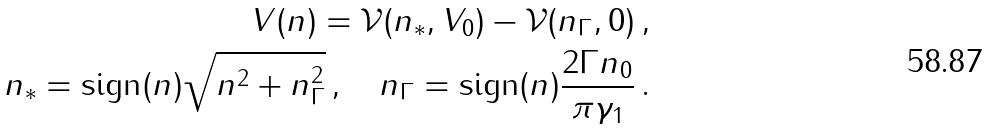Convert formula to latex. <formula><loc_0><loc_0><loc_500><loc_500>V ( n ) = \mathcal { V } ( n _ { * } , V _ { 0 } ) - \mathcal { V } ( n _ { \Gamma } , 0 ) \, , \\ n _ { * } = \text {sign} ( n ) \sqrt { n ^ { 2 } + n _ { \Gamma } ^ { 2 } } \, , \quad n _ { \Gamma } = \text {sign} ( n ) \frac { 2 \Gamma n _ { 0 } } { \pi \gamma _ { 1 } } \, .</formula> 